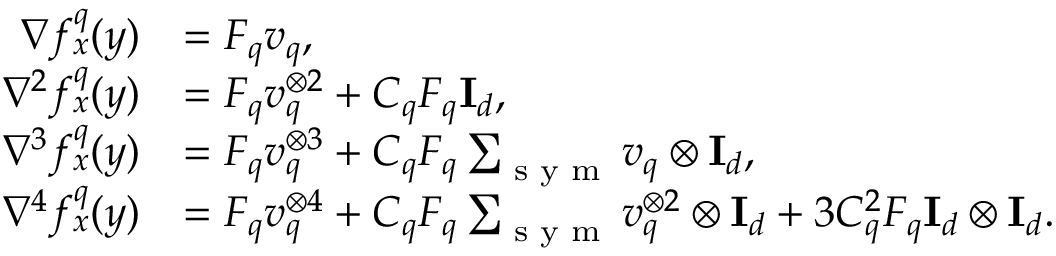Convert formula to latex. <formula><loc_0><loc_0><loc_500><loc_500>\begin{array} { r l } { \nabla f _ { x } ^ { q } ( y ) } & { = F _ { q } v _ { q } , } \\ { \nabla ^ { 2 } f _ { x } ^ { q } ( y ) } & { = F _ { q } v _ { q } ^ { \otimes 2 } + C _ { q } F _ { q } I _ { d } , } \\ { \nabla ^ { 3 } f _ { x } ^ { q } ( y ) } & { = F _ { q } v _ { q } ^ { \otimes 3 } + C _ { q } F _ { q } \sum _ { s y m } v _ { q } \otimes I _ { d } , } \\ { \nabla ^ { 4 } f _ { x } ^ { q } ( y ) } & { = F _ { q } v _ { q } ^ { \otimes 4 } + C _ { q } F _ { q } \sum _ { s y m } v _ { q } ^ { \otimes 2 } \otimes I _ { d } + 3 C _ { q } ^ { 2 } F _ { q } I _ { d } \otimes I _ { d } . } \end{array}</formula> 